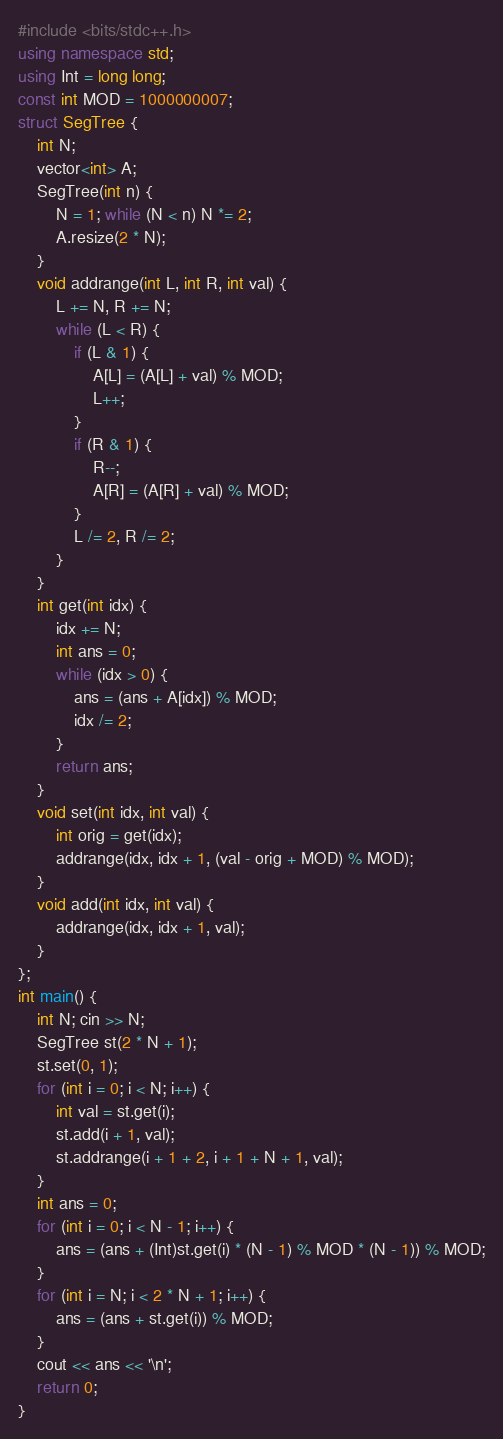Convert code to text. <code><loc_0><loc_0><loc_500><loc_500><_C++_>#include <bits/stdc++.h>
using namespace std;
using Int = long long;
const int MOD = 1000000007;
struct SegTree {
    int N;
    vector<int> A;
    SegTree(int n) {
        N = 1; while (N < n) N *= 2;
        A.resize(2 * N);
    }
    void addrange(int L, int R, int val) {
        L += N, R += N;
        while (L < R) {
            if (L & 1) {
                A[L] = (A[L] + val) % MOD;
                L++;
            }
            if (R & 1) {
                R--;
                A[R] = (A[R] + val) % MOD;
            }
            L /= 2, R /= 2;
        }
    }
    int get(int idx) {
        idx += N;
        int ans = 0;
        while (idx > 0) {
            ans = (ans + A[idx]) % MOD;
            idx /= 2;
        }
        return ans;
    }
    void set(int idx, int val) {
        int orig = get(idx);
        addrange(idx, idx + 1, (val - orig + MOD) % MOD);
    }
    void add(int idx, int val) {
        addrange(idx, idx + 1, val);
    }
};
int main() {
    int N; cin >> N;
    SegTree st(2 * N + 1);
    st.set(0, 1);
    for (int i = 0; i < N; i++) {
        int val = st.get(i);
        st.add(i + 1, val);
        st.addrange(i + 1 + 2, i + 1 + N + 1, val);
    }
    int ans = 0;
    for (int i = 0; i < N - 1; i++) {
        ans = (ans + (Int)st.get(i) * (N - 1) % MOD * (N - 1)) % MOD;
    }
    for (int i = N; i < 2 * N + 1; i++) {
        ans = (ans + st.get(i)) % MOD;
    }
    cout << ans << '\n';
    return 0;
}
</code> 